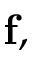<formula> <loc_0><loc_0><loc_500><loc_500>f ,</formula> 